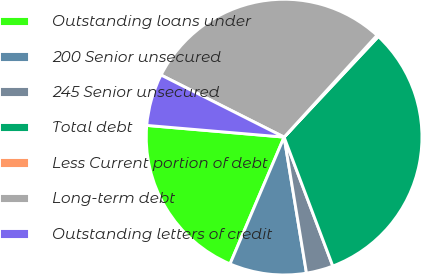<chart> <loc_0><loc_0><loc_500><loc_500><pie_chart><fcel>Outstanding loans under<fcel>200 Senior unsecured<fcel>245 Senior unsecured<fcel>Total debt<fcel>Less Current portion of debt<fcel>Long-term debt<fcel>Outstanding letters of credit<nl><fcel>19.94%<fcel>9.01%<fcel>3.15%<fcel>32.27%<fcel>0.21%<fcel>29.34%<fcel>6.08%<nl></chart> 